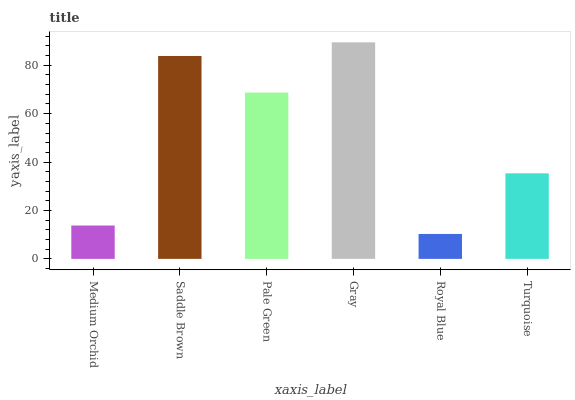Is Royal Blue the minimum?
Answer yes or no. Yes. Is Gray the maximum?
Answer yes or no. Yes. Is Saddle Brown the minimum?
Answer yes or no. No. Is Saddle Brown the maximum?
Answer yes or no. No. Is Saddle Brown greater than Medium Orchid?
Answer yes or no. Yes. Is Medium Orchid less than Saddle Brown?
Answer yes or no. Yes. Is Medium Orchid greater than Saddle Brown?
Answer yes or no. No. Is Saddle Brown less than Medium Orchid?
Answer yes or no. No. Is Pale Green the high median?
Answer yes or no. Yes. Is Turquoise the low median?
Answer yes or no. Yes. Is Gray the high median?
Answer yes or no. No. Is Pale Green the low median?
Answer yes or no. No. 